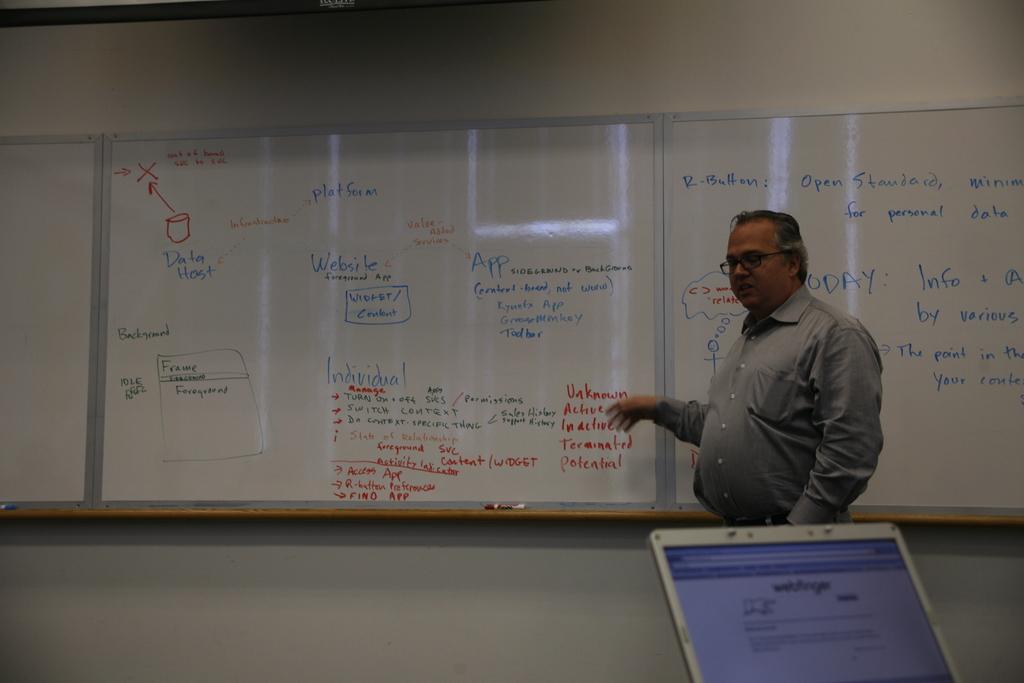Is there any word visible on that screen?
Your answer should be very brief. Yes. 